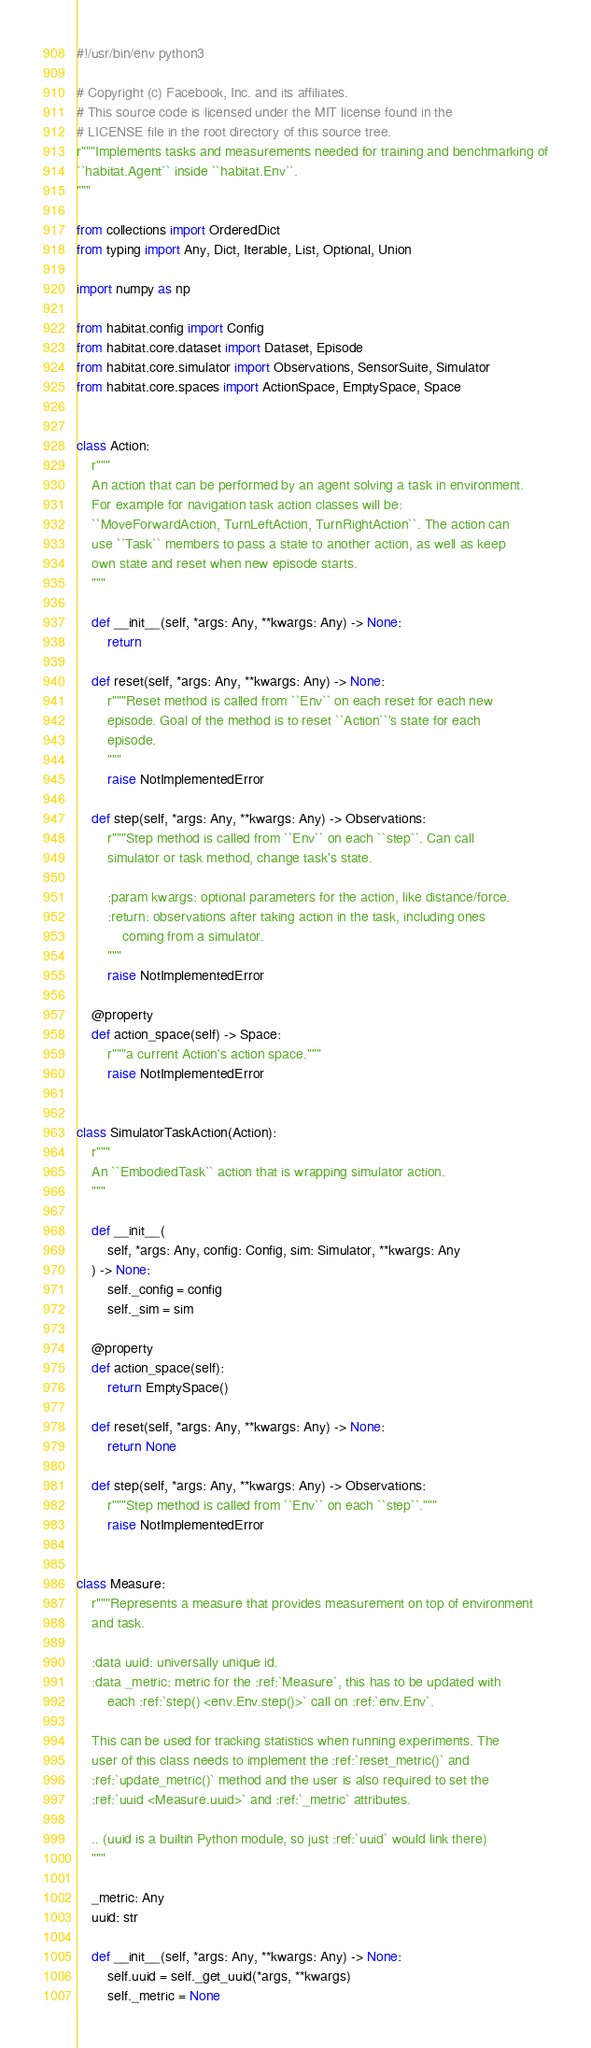<code> <loc_0><loc_0><loc_500><loc_500><_Python_>#!/usr/bin/env python3

# Copyright (c) Facebook, Inc. and its affiliates.
# This source code is licensed under the MIT license found in the
# LICENSE file in the root directory of this source tree.
r"""Implements tasks and measurements needed for training and benchmarking of
``habitat.Agent`` inside ``habitat.Env``.
"""

from collections import OrderedDict
from typing import Any, Dict, Iterable, List, Optional, Union

import numpy as np

from habitat.config import Config
from habitat.core.dataset import Dataset, Episode
from habitat.core.simulator import Observations, SensorSuite, Simulator
from habitat.core.spaces import ActionSpace, EmptySpace, Space


class Action:
    r"""
    An action that can be performed by an agent solving a task in environment.
    For example for navigation task action classes will be:
    ``MoveForwardAction, TurnLeftAction, TurnRightAction``. The action can
    use ``Task`` members to pass a state to another action, as well as keep
    own state and reset when new episode starts.
    """

    def __init__(self, *args: Any, **kwargs: Any) -> None:
        return

    def reset(self, *args: Any, **kwargs: Any) -> None:
        r"""Reset method is called from ``Env`` on each reset for each new
        episode. Goal of the method is to reset ``Action``'s state for each
        episode.
        """
        raise NotImplementedError

    def step(self, *args: Any, **kwargs: Any) -> Observations:
        r"""Step method is called from ``Env`` on each ``step``. Can call
        simulator or task method, change task's state.

        :param kwargs: optional parameters for the action, like distance/force.
        :return: observations after taking action in the task, including ones
            coming from a simulator.
        """
        raise NotImplementedError

    @property
    def action_space(self) -> Space:
        r"""a current Action's action space."""
        raise NotImplementedError


class SimulatorTaskAction(Action):
    r"""
    An ``EmbodiedTask`` action that is wrapping simulator action.
    """

    def __init__(
        self, *args: Any, config: Config, sim: Simulator, **kwargs: Any
    ) -> None:
        self._config = config
        self._sim = sim

    @property
    def action_space(self):
        return EmptySpace()

    def reset(self, *args: Any, **kwargs: Any) -> None:
        return None

    def step(self, *args: Any, **kwargs: Any) -> Observations:
        r"""Step method is called from ``Env`` on each ``step``."""
        raise NotImplementedError


class Measure:
    r"""Represents a measure that provides measurement on top of environment
    and task.

    :data uuid: universally unique id.
    :data _metric: metric for the :ref:`Measure`, this has to be updated with
        each :ref:`step() <env.Env.step()>` call on :ref:`env.Env`.

    This can be used for tracking statistics when running experiments. The
    user of this class needs to implement the :ref:`reset_metric()` and
    :ref:`update_metric()` method and the user is also required to set the
    :ref:`uuid <Measure.uuid>` and :ref:`_metric` attributes.

    .. (uuid is a builtin Python module, so just :ref:`uuid` would link there)
    """

    _metric: Any
    uuid: str

    def __init__(self, *args: Any, **kwargs: Any) -> None:
        self.uuid = self._get_uuid(*args, **kwargs)
        self._metric = None
</code> 